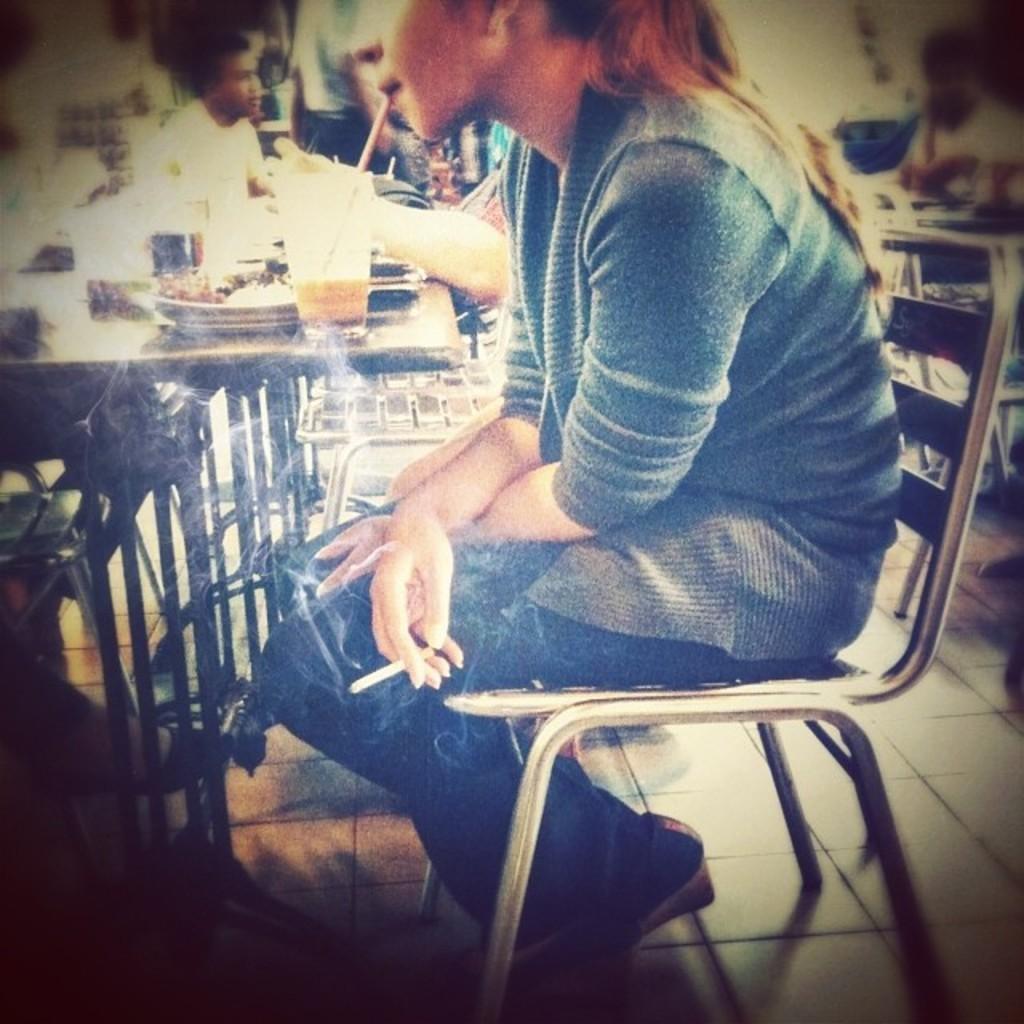In one or two sentences, can you explain what this image depicts? In this image I can see a girl is sitting on a chair, I can also see she is holding a cigarette. In the background I can see few more people. On this table I can see a glass and few more plates. 